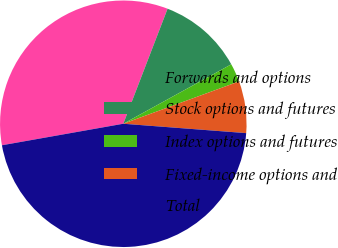Convert chart to OTSL. <chart><loc_0><loc_0><loc_500><loc_500><pie_chart><fcel>Forwards and options<fcel>Stock options and futures<fcel>Index options and futures<fcel>Fixed-income options and<fcel>Total<nl><fcel>33.64%<fcel>11.14%<fcel>2.43%<fcel>6.79%<fcel>45.99%<nl></chart> 